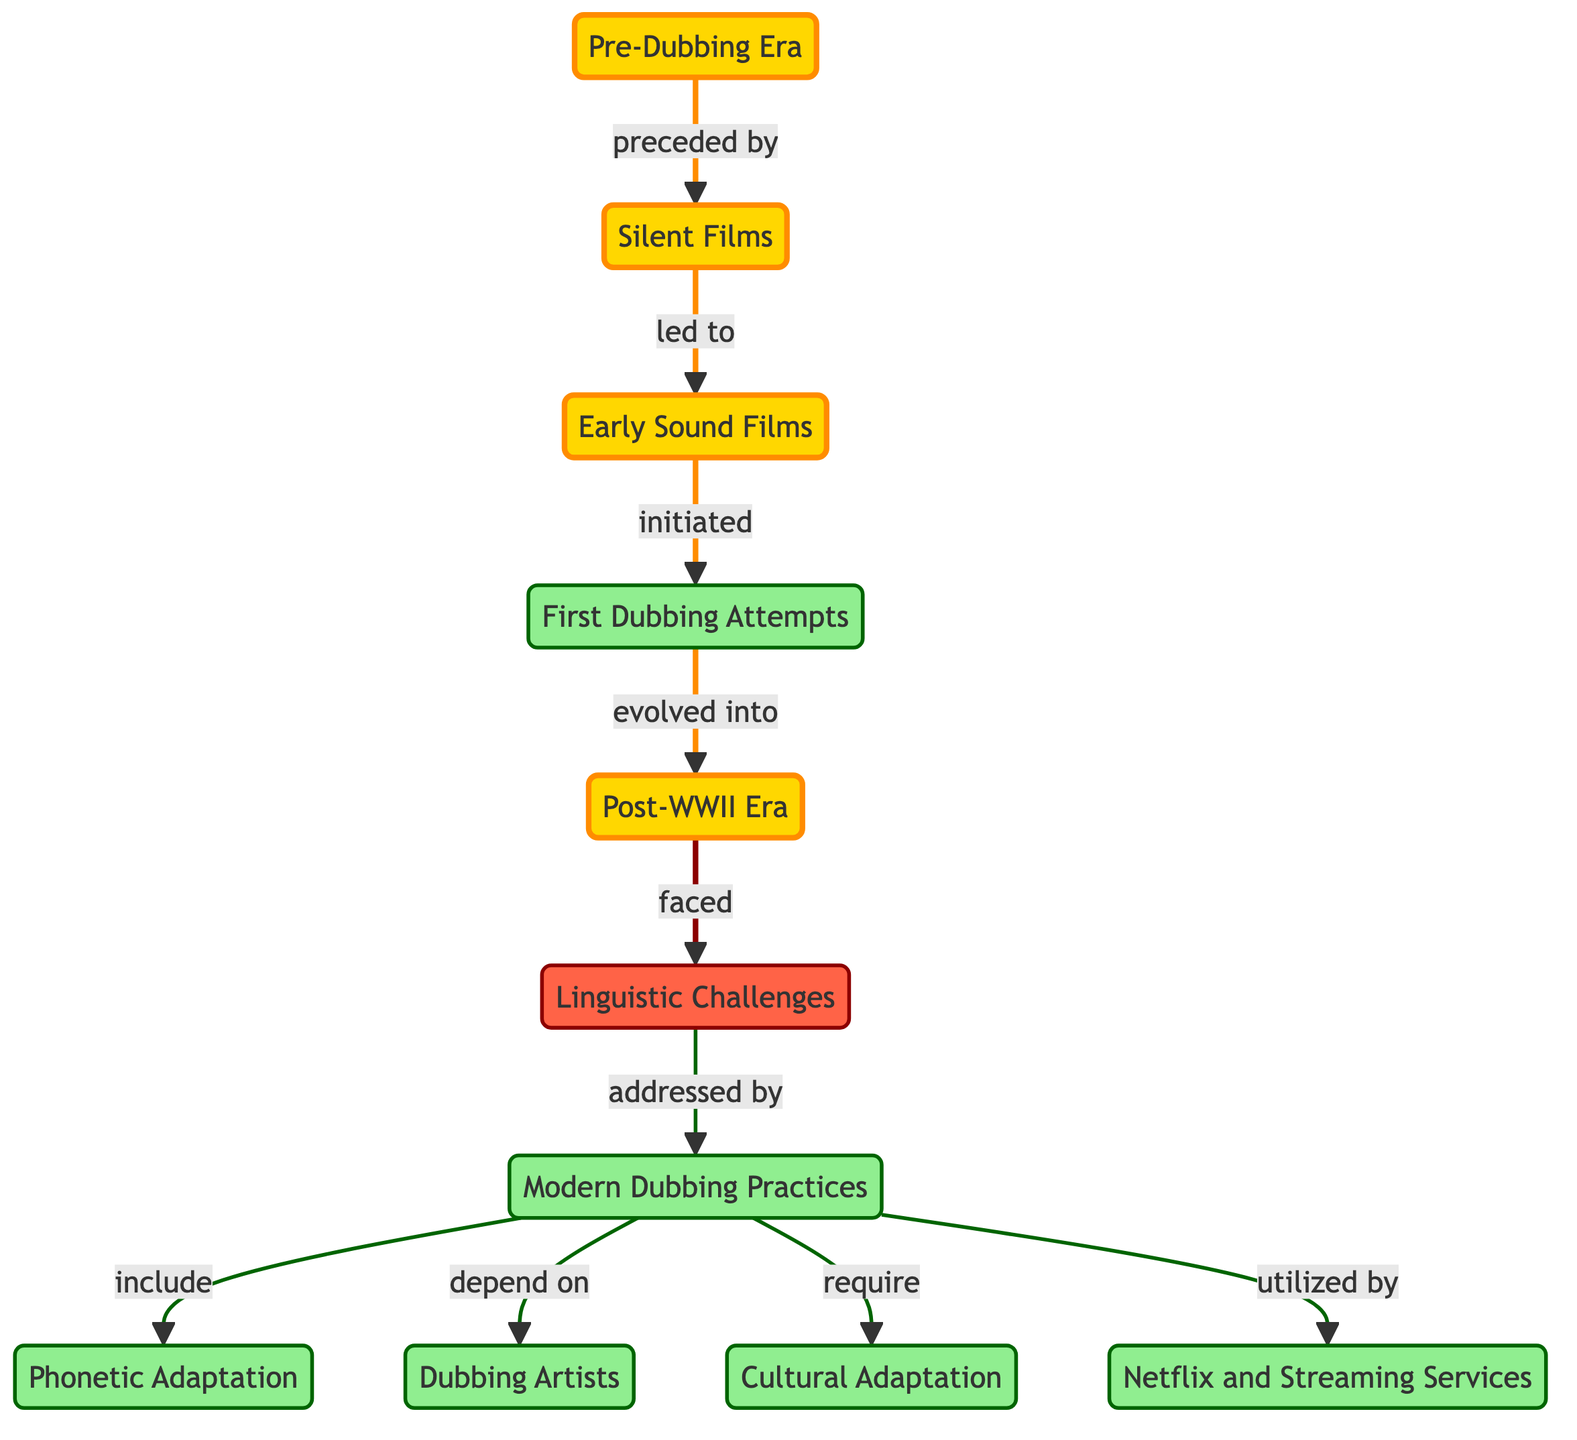What is the first node representing the earliest period in film history? The diagram shows "Pre-Dubbing Era" as the starting node at the top, indicating the period before sound was introduced in films.
Answer: Pre-Dubbing Era How many nodes are present in the diagram? By counting all the unique labeled nodes displayed in the diagram, we find that there are 11 nodes in total.
Answer: 11 What relationship exists between "First Dubbing Attempts" and "Post-WWII Era"? The diagram specifies that "First Dubbing Attempts" evolved into "Post-WWII Era," showing a direct progression from early dubbing efforts to a more developed era after World War II.
Answer: evolved into Which node addresses issues faced during the "Post-WWII Era"? According to the diagram, "Linguistic Challenges" is the node that directly follows and addresses the problems faced during the "Post-WWII Era."
Answer: Linguistic Challenges What key practices are included in the "Modern Dubbing Practices"? The diagram indicates that "Phonetic Adaptation," "Dubbing Artists," and "Cultural Adaptation" are all part of the practices included under "Modern Dubbing Practices."
Answer: Phonetic Adaptation Which platforms have popularized dubbed content, as shown in the diagram? The node "Netflix and Streaming Services" is depicted as being utilized by "Modern Dubbing Practices," indicating their significant role in the dubbing landscape today.
Answer: Netflix and Streaming Services What challenges does "Modern Dubbing Practices" have to address? The diagram reveals that "Modern Dubbing Practices" must address "Linguistic Challenges," which are the issues encountered in the dubbing process.
Answer: Linguistic Challenges What initiated the era of dubbing as per the flow of the diagram? The progression shows that "Early Sound Films" initiated the first attempts at dubbing, marking the beginning of synchronized foreign language dialogues.
Answer: initiated How do modern dubbing practices relate to phonetics as per the diagram? The relationship indicates that "Phonetic Adaptation" is included in "Modern Dubbing Practices," signifying the application of phonetic principles in contemporary dubbing.
Answer: include 